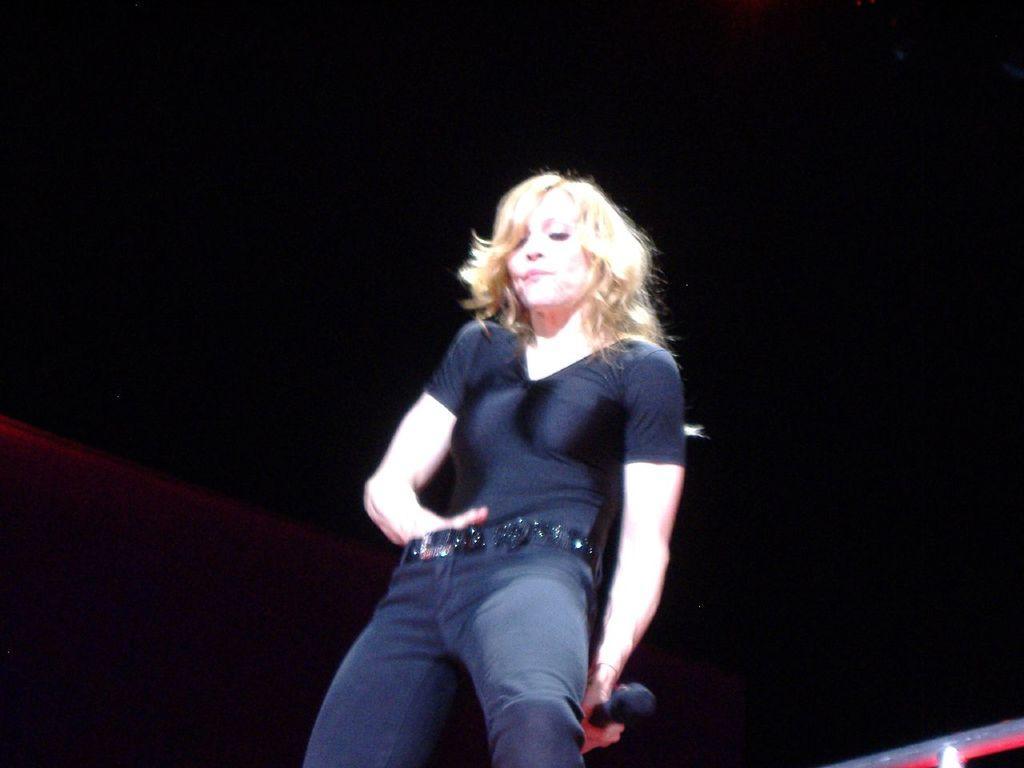Please provide a concise description of this image. This image consists of a woman wearing black dress is holding a mic in her hand. The background is too dark. 